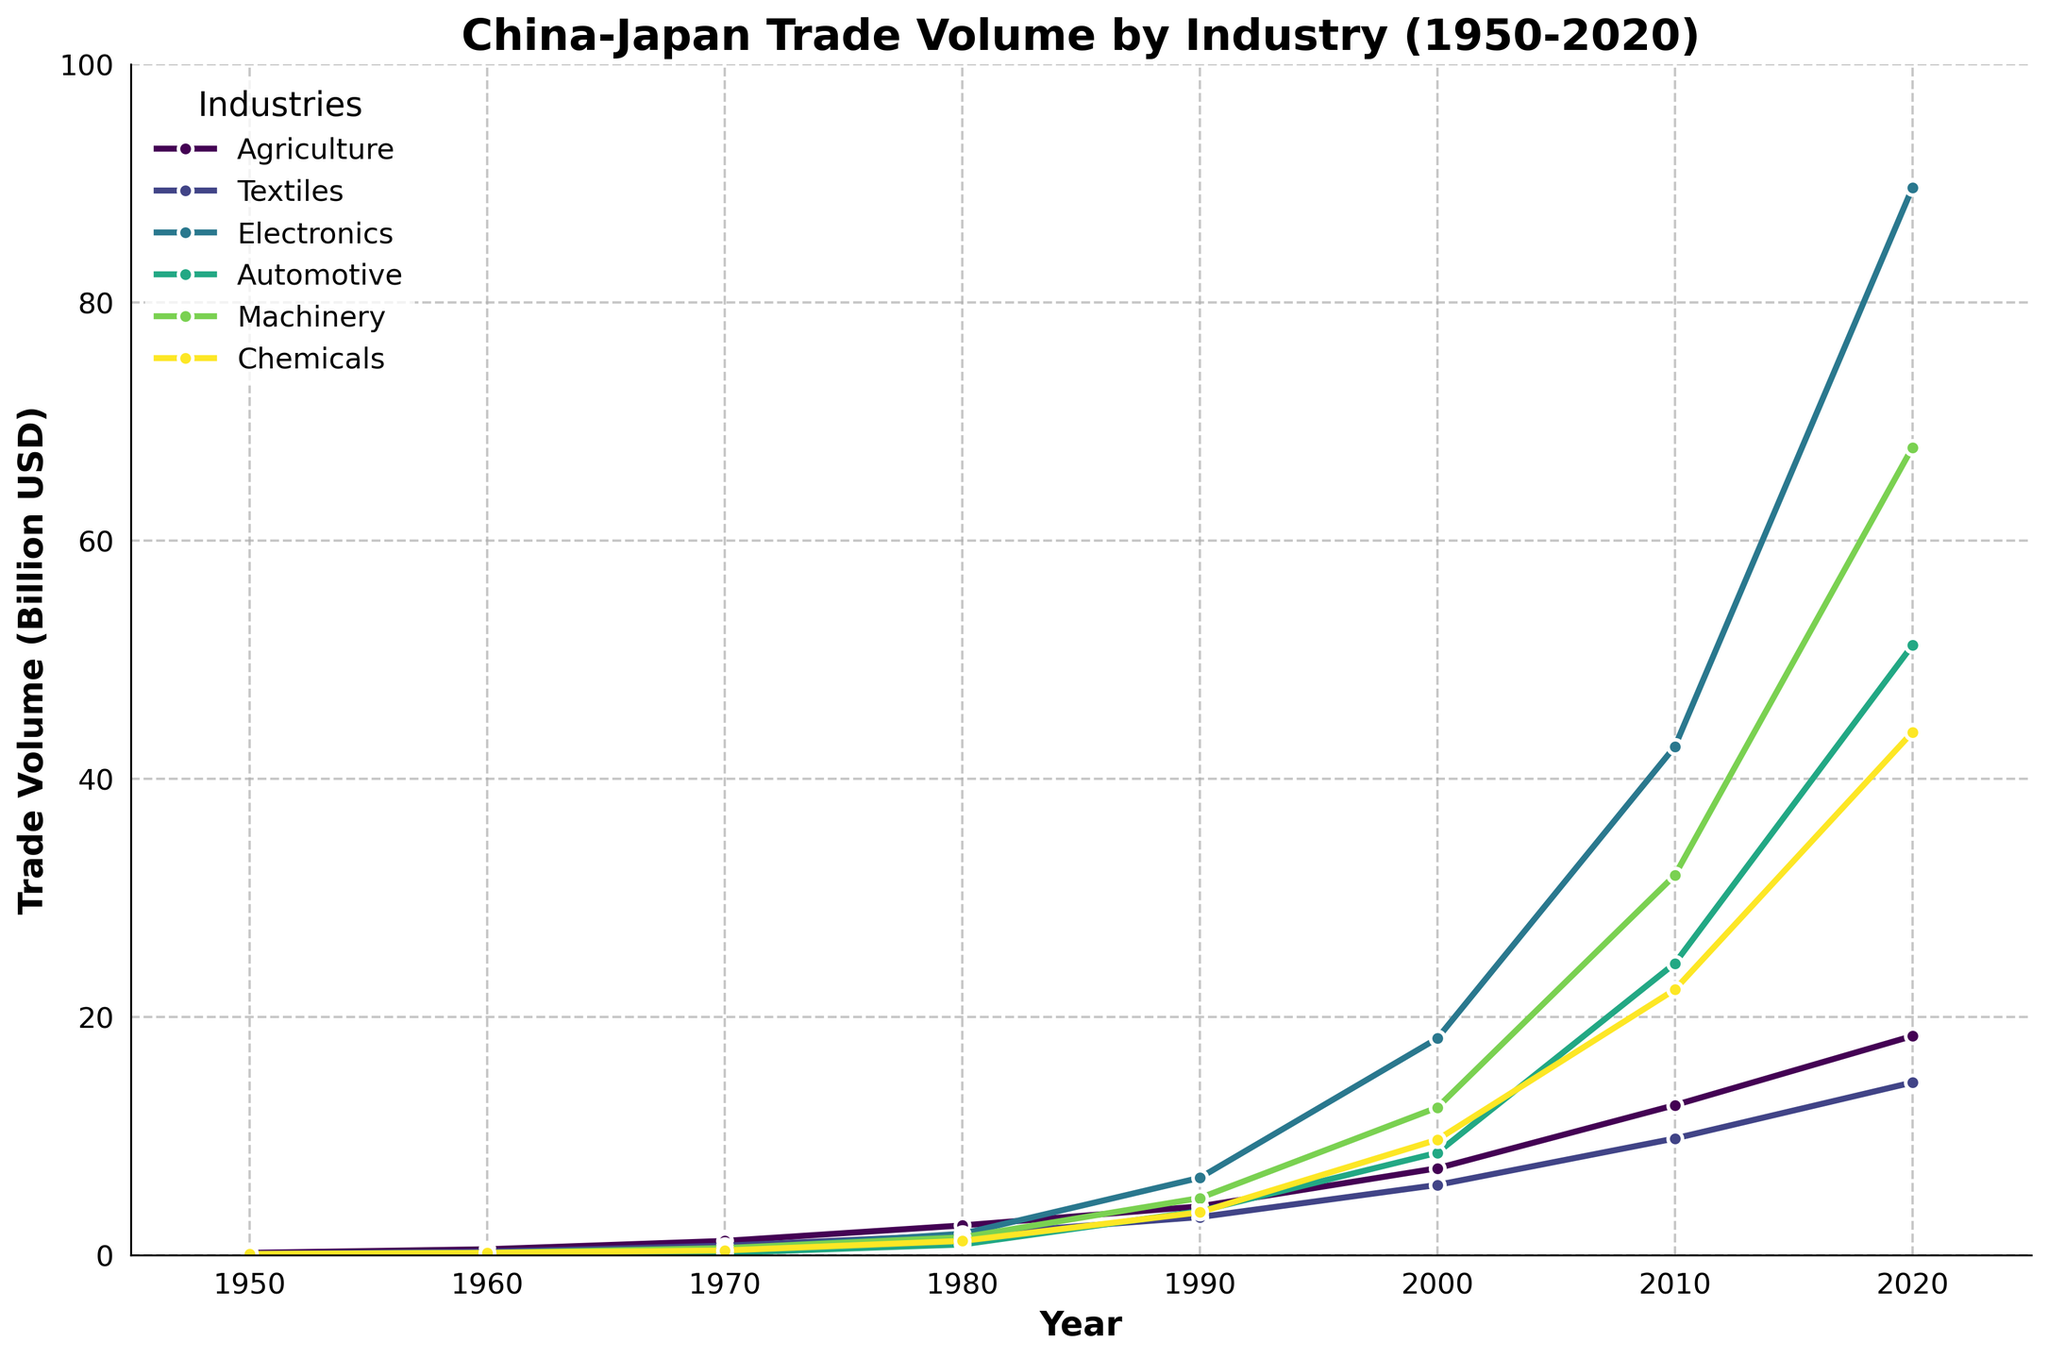Which industry had the highest trade volume in 2020? The highest trade volume in 2020 can be identified by looking at the final data points of each line. The Electronics industry has the highest endpoint.
Answer: Electronics How did the trade volume in the Automotive industry change from 1980 to 2020? In 1980, the trade volume for Automotive was 0.9 billion USD. In 2020, it was 51.2 billion USD. The change is 51.2 - 0.9 = 50.3 billion USD.
Answer: 50.3 billion USD Which two industries saw the most significant increase in trade volume from 2000 to 2010? Comparing line slopes between 2000 and 2010, Electronics and Machinery industries have the steepest slopes. Electronics increased from 18.2 to 42.7 and Machinery from 12.4 to 31.9.
Answer: Electronics, Machinery What was the total trade volume of the Agriculture and Textiles industries in 1990? In 1990, Agriculture volume was 4.1 billion USD and Textiles was 3.2 billion USD. The total is 4.1 + 3.2 = 7.3 billion USD.
Answer: 7.3 billion USD Compare the trade volumes of Machinery and Chemicals in the year 2000. Which one was higher? In 2000, the trade volume for Machinery was 12.4 billion USD while for Chemicals it was 9.7 billion USD. Therefore, Machinery had a higher trade volume.
Answer: Machinery What is the average trade volume of Agriculture from 1950 to 2020? Summing the Agriculture volumes: 0.2, 0.5, 1.2, 2.5, 4.1, 7.3, 12.6, 18.4. The total is 46.8. Divided by 8 (number of years), the average is 46.8/8 = 5.85 billion USD.
Answer: 5.85 billion USD What was the trade volume difference between Textiles and Electronics in 1980? In 1980, Textiles had a volume of 1.7 billion USD and Electronics had a volume of 1.8 billion USD. The difference is 1.8 - 1.7 = 0.1 billion USD.
Answer: 0.1 billion USD Which industry had the lowest trade volume in 1960? In 1960, Electronics had the lowest trade volume with 0.1 billion USD, as compared to other industries.
Answer: Electronics What was the combined trade volume of all industries in 2010? Summing the trade volumes in 2010: 12.6 (Agriculture) + 9.8 (Textiles) + 42.7 (Electronics) + 24.5 (Automotive) + 31.9 (Machinery) + 22.3 (Chemicals). The total is 143.8 billion USD.
Answer: 143.8 billion USD Which industry showed the smallest increase in trade volume from 1990 to 2000? Comparing trade volume increases from 1990 to 2000: Agriculture (3.2), Textiles (2.7), Electronics (11.7), Automotive (4.9), Machinery (7.6), Chemicals (6.1). Textiles showed the smallest increase of 2.7 billion USD.
Answer: Textiles 